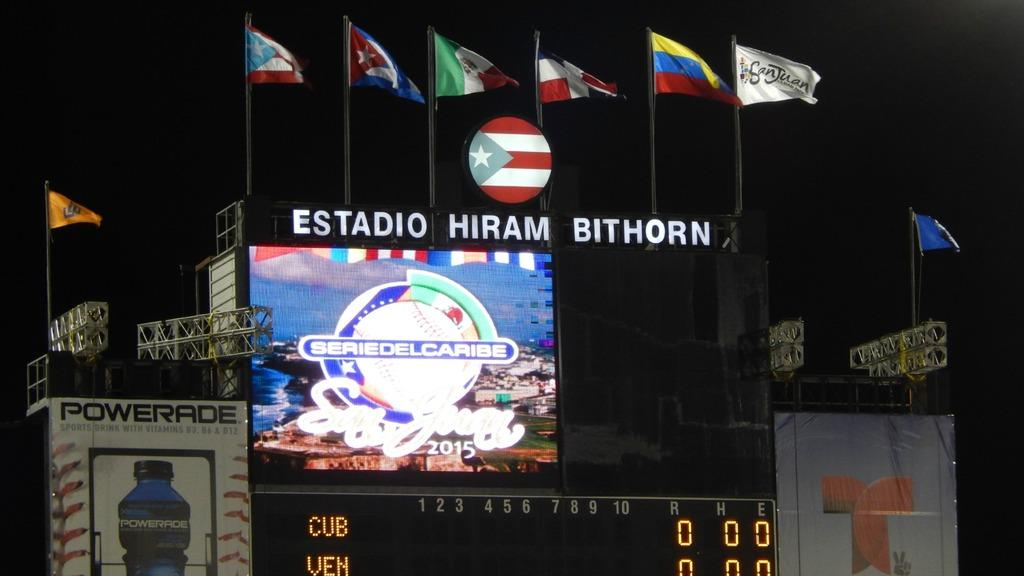Provide a one-sentence caption for the provided image. a sign above a scoreboard that says 'estadio hiram bithorn'. 